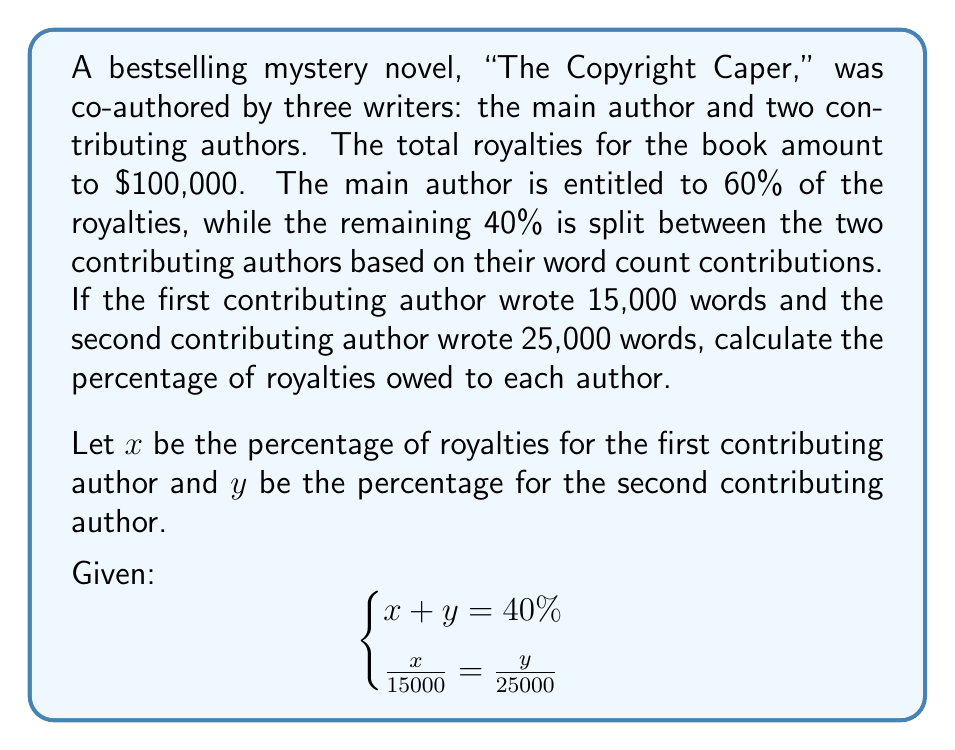Could you help me with this problem? To solve this system of equations, we'll follow these steps:

1) From the first equation, we know that the total percentage for the contributing authors is 40%:
   $$x + y = 40\%$$

2) The second equation shows that the royalty percentages are proportional to the word counts:
   $$\frac{x}{15000} = \frac{y}{25000}$$

3) We can simplify this by cross-multiplying:
   $$25000x = 15000y$$

4) Solve for y in terms of x:
   $$y = \frac{25000x}{15000} = \frac{5x}{3}$$

5) Substitute this into the first equation:
   $$x + \frac{5x}{3} = 40\%$$

6) Simplify:
   $$\frac{3x}{3} + \frac{5x}{3} = 40\%$$
   $$\frac{8x}{3} = 40\%$$

7) Solve for x:
   $$x = 40\% \cdot \frac{3}{8} = 15\%$$

8) Now we can find y by substituting x back into the equation from step 4:
   $$y = \frac{5(15\%)}{3} = 25\%$$

9) Verify that x + y = 40%:
   $$15\% + 25\% = 40\%$$

10) Calculate the main author's percentage:
    $$100\% - 40\% = 60\%$$

Therefore, the royalty percentages are:
- Main author: 60%
- First contributing author: 15%
- Second contributing author: 25%
Answer: Main author: 60%
First contributing author: 15%
Second contributing author: 25% 